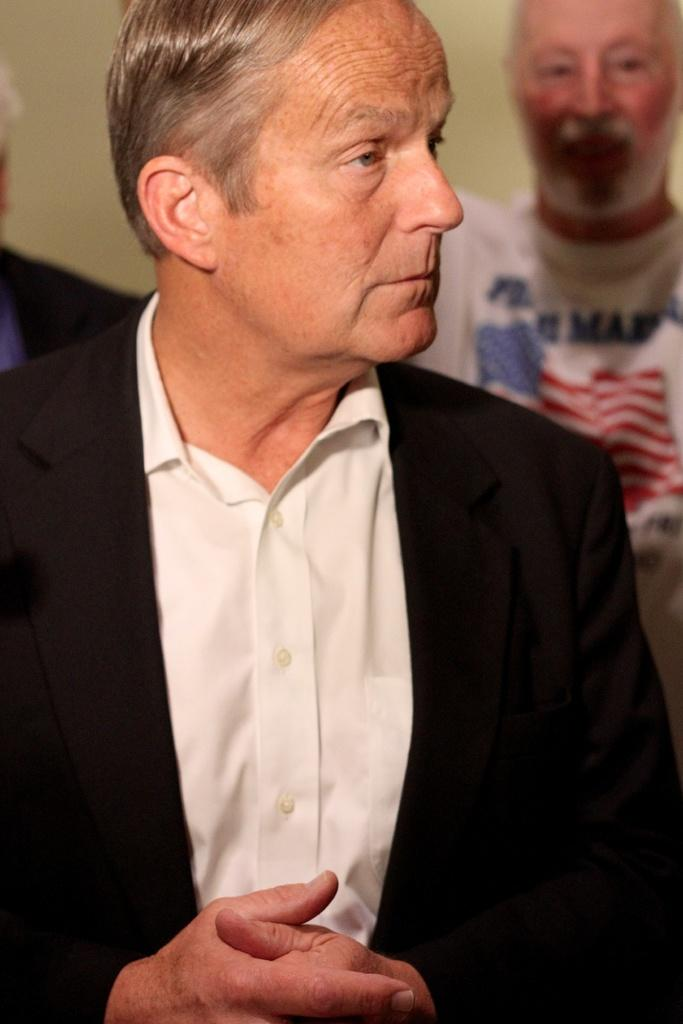How many people are visible in the image? There are a few people in the image. Which person is given more prominence in the image? One person is highlighted in the front. What can be observed about the background of the image? The background of the image is blurred. What type of guitar is being played by the person in the image? There is no guitar present in the image; it only features a few people, with one person highlighted in the front. 